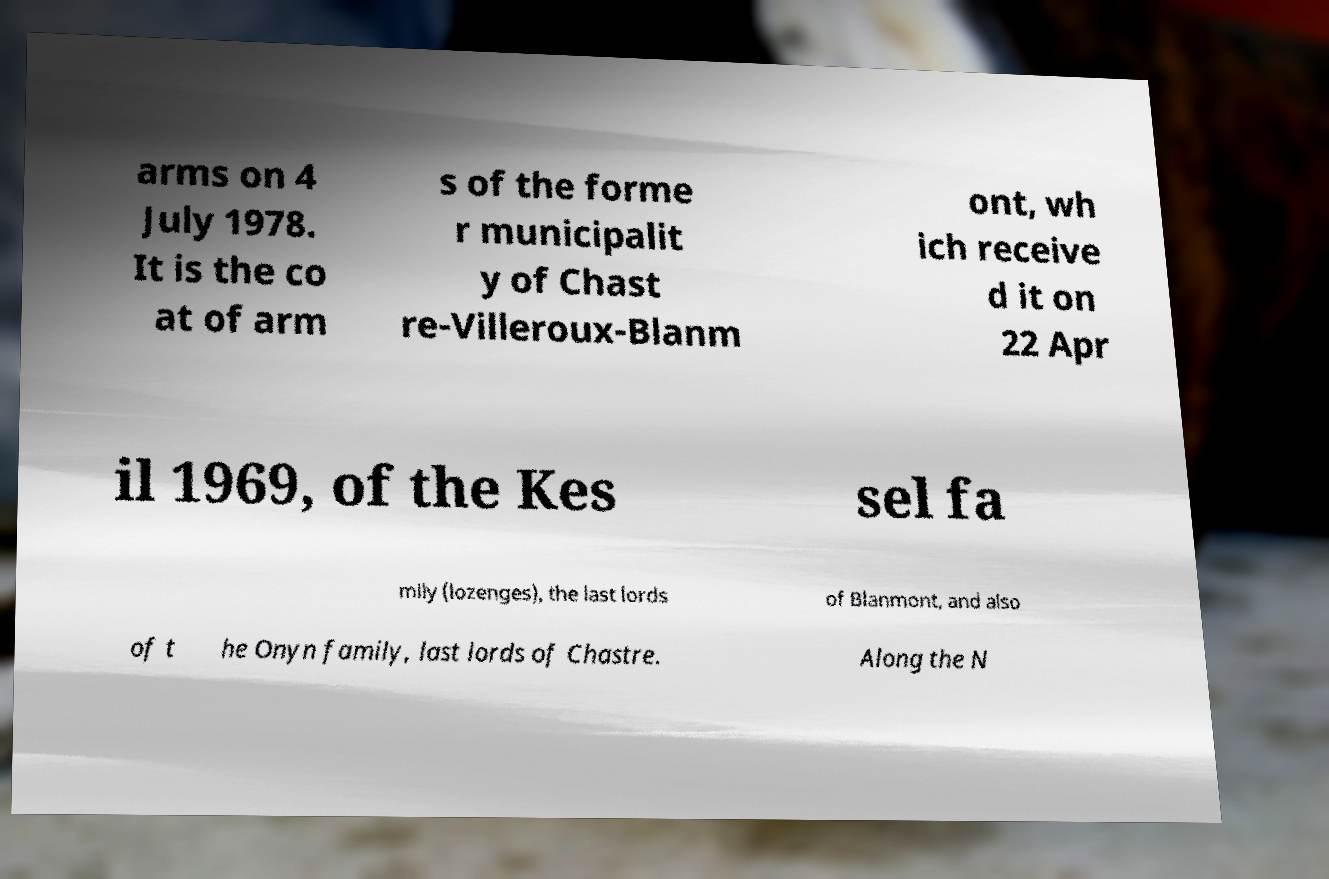Please read and relay the text visible in this image. What does it say? arms on 4 July 1978. It is the co at of arm s of the forme r municipalit y of Chast re-Villeroux-Blanm ont, wh ich receive d it on 22 Apr il 1969, of the Kes sel fa mily (lozenges), the last lords of Blanmont, and also of t he Onyn family, last lords of Chastre. Along the N 